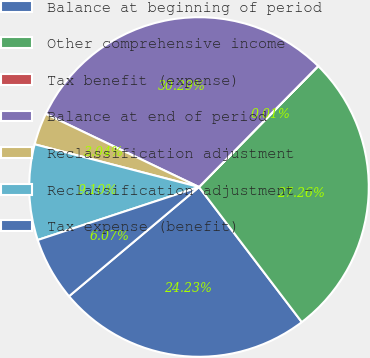Convert chart. <chart><loc_0><loc_0><loc_500><loc_500><pie_chart><fcel>Balance at beginning of period<fcel>Other comprehensive income<fcel>Tax benefit (expense)<fcel>Balance at end of period<fcel>Reclassification adjustment<fcel>Reclassification adjustment -<fcel>Tax expense (benefit)<nl><fcel>24.23%<fcel>27.26%<fcel>0.01%<fcel>30.29%<fcel>3.04%<fcel>9.1%<fcel>6.07%<nl></chart> 